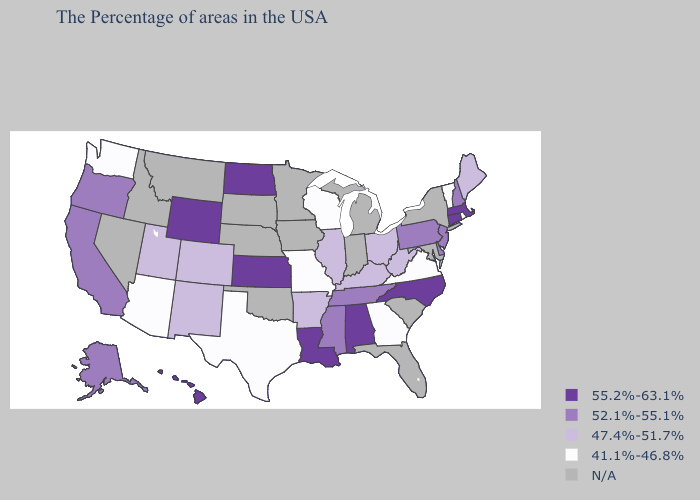What is the value of Vermont?
Give a very brief answer. 41.1%-46.8%. Name the states that have a value in the range 41.1%-46.8%?
Answer briefly. Rhode Island, Vermont, Virginia, Georgia, Wisconsin, Missouri, Texas, Arizona, Washington. What is the value of Georgia?
Answer briefly. 41.1%-46.8%. What is the lowest value in states that border Alabama?
Quick response, please. 41.1%-46.8%. Name the states that have a value in the range 55.2%-63.1%?
Quick response, please. Massachusetts, Connecticut, North Carolina, Alabama, Louisiana, Kansas, North Dakota, Wyoming, Hawaii. What is the value of Tennessee?
Keep it brief. 52.1%-55.1%. Which states have the lowest value in the MidWest?
Be succinct. Wisconsin, Missouri. Which states have the lowest value in the USA?
Concise answer only. Rhode Island, Vermont, Virginia, Georgia, Wisconsin, Missouri, Texas, Arizona, Washington. What is the value of Minnesota?
Answer briefly. N/A. What is the highest value in states that border Montana?
Quick response, please. 55.2%-63.1%. Name the states that have a value in the range 47.4%-51.7%?
Give a very brief answer. Maine, West Virginia, Ohio, Kentucky, Illinois, Arkansas, Colorado, New Mexico, Utah. What is the value of Kentucky?
Concise answer only. 47.4%-51.7%. What is the value of Georgia?
Quick response, please. 41.1%-46.8%. What is the lowest value in the USA?
Short answer required. 41.1%-46.8%. Does New Jersey have the lowest value in the Northeast?
Quick response, please. No. 